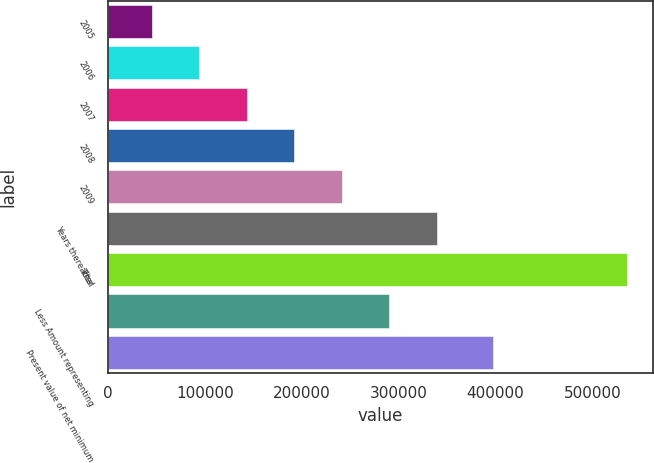<chart> <loc_0><loc_0><loc_500><loc_500><bar_chart><fcel>2005<fcel>2006<fcel>2007<fcel>2008<fcel>2009<fcel>Years thereafter<fcel>Total<fcel>Less Amount representing<fcel>Present value of net minimum<nl><fcel>45423<fcel>94409.1<fcel>143395<fcel>192381<fcel>241367<fcel>339340<fcel>535284<fcel>290354<fcel>397119<nl></chart> 